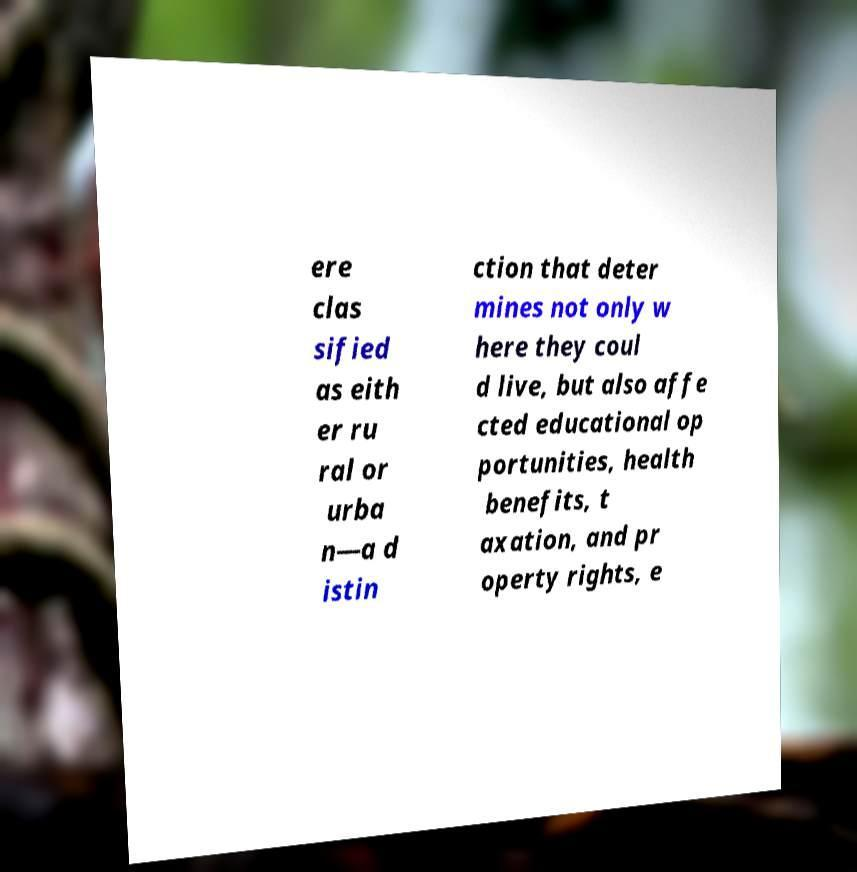I need the written content from this picture converted into text. Can you do that? ere clas sified as eith er ru ral or urba n—a d istin ction that deter mines not only w here they coul d live, but also affe cted educational op portunities, health benefits, t axation, and pr operty rights, e 